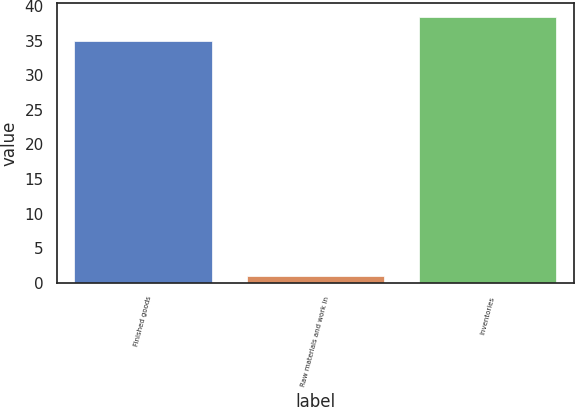Convert chart. <chart><loc_0><loc_0><loc_500><loc_500><bar_chart><fcel>Finished goods<fcel>Raw materials and work in<fcel>Inventories<nl><fcel>35<fcel>1<fcel>38.5<nl></chart> 